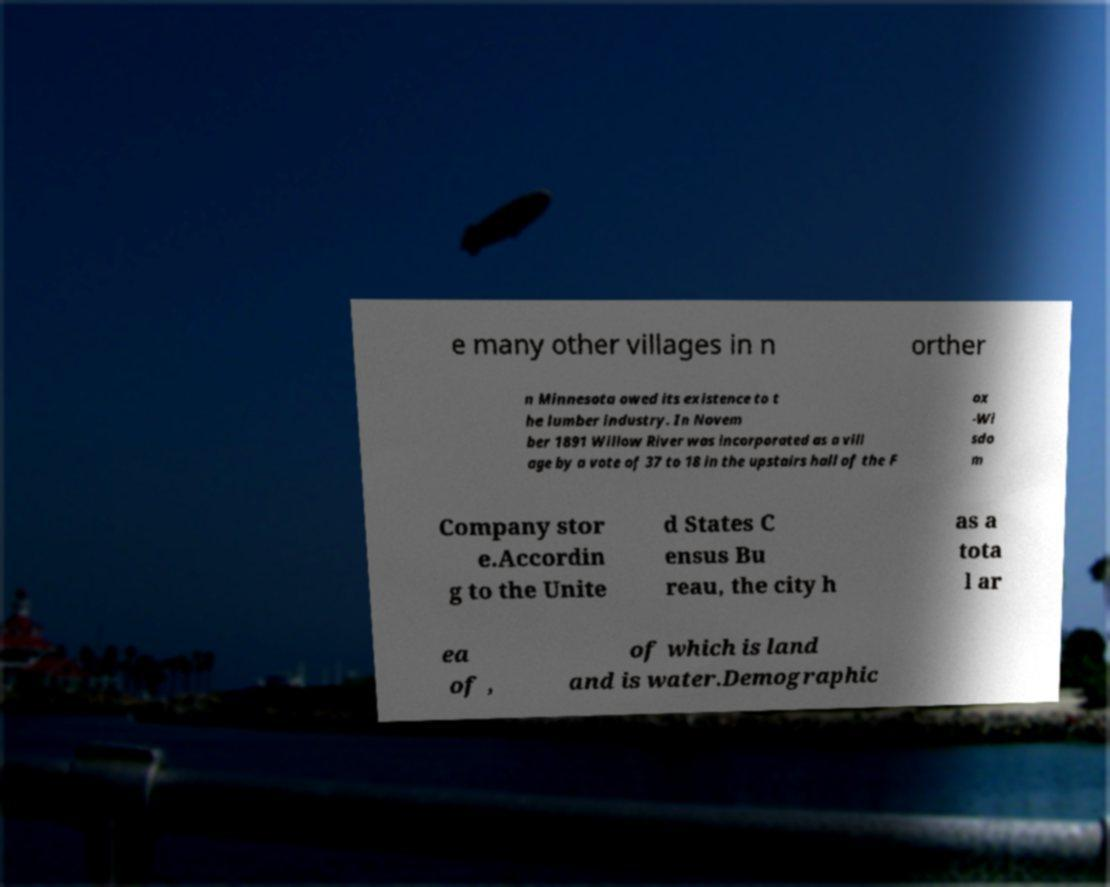For documentation purposes, I need the text within this image transcribed. Could you provide that? e many other villages in n orther n Minnesota owed its existence to t he lumber industry. In Novem ber 1891 Willow River was incorporated as a vill age by a vote of 37 to 18 in the upstairs hall of the F ox -Wi sdo m Company stor e.Accordin g to the Unite d States C ensus Bu reau, the city h as a tota l ar ea of , of which is land and is water.Demographic 